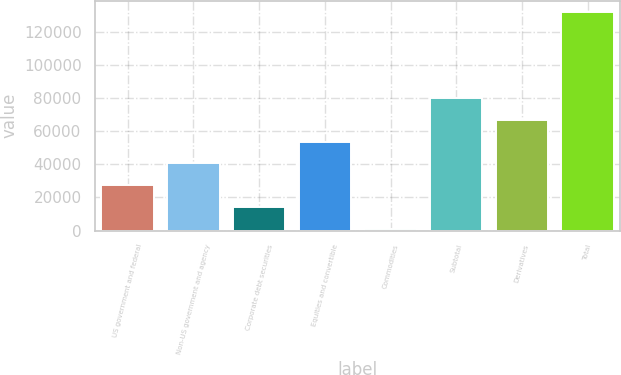Convert chart to OTSL. <chart><loc_0><loc_0><loc_500><loc_500><bar_chart><fcel>US government and federal<fcel>Non-US government and agency<fcel>Corporate debt securities<fcel>Equities and convertible<fcel>Commodities<fcel>Subtotal<fcel>Derivatives<fcel>Total<nl><fcel>27395.8<fcel>40481.7<fcel>14309.9<fcel>53567.6<fcel>1224<fcel>79739.4<fcel>66653.5<fcel>132083<nl></chart> 